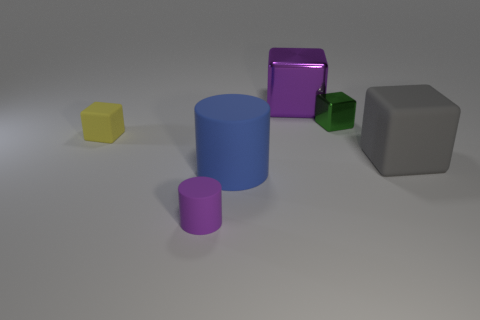There is a rubber cube left of the gray matte object; what color is it?
Provide a short and direct response. Yellow. Is the material of the gray thing the same as the purple object left of the large blue matte cylinder?
Ensure brevity in your answer.  Yes. What is the small yellow block made of?
Offer a terse response. Rubber. There is another large object that is made of the same material as the large blue thing; what shape is it?
Provide a short and direct response. Cube. What number of other things are the same shape as the yellow rubber thing?
Ensure brevity in your answer.  3. How many small matte objects are behind the tiny yellow matte object?
Offer a very short reply. 0. There is a blue matte object left of the green shiny thing; is it the same size as the rubber cylinder in front of the large blue rubber cylinder?
Your response must be concise. No. What number of other objects are the same size as the yellow rubber thing?
Keep it short and to the point. 2. What is the material of the cylinder to the left of the cylinder that is behind the thing in front of the big cylinder?
Your answer should be very brief. Rubber. Are there the same number of big shiny objects and small brown shiny blocks?
Ensure brevity in your answer.  No. 